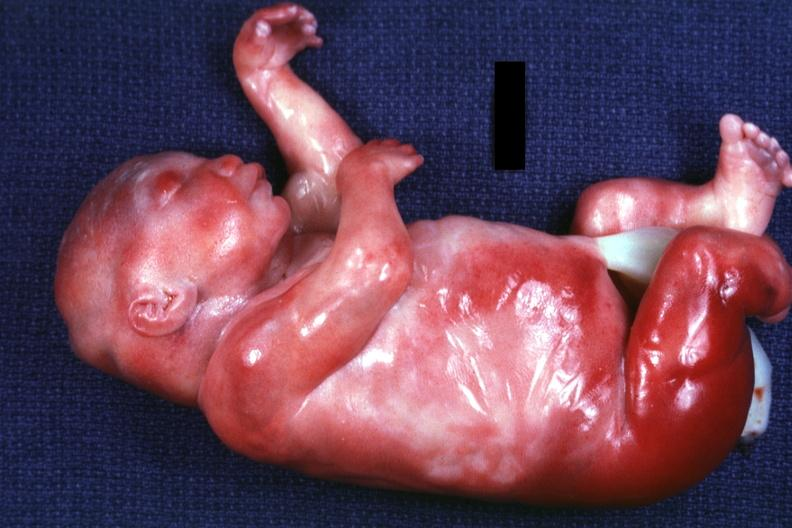how many digits do a barely seen vascular mass extruding from occipital region of skull arms and legs appear too short has?
Answer the question using a single word or phrase. Six 